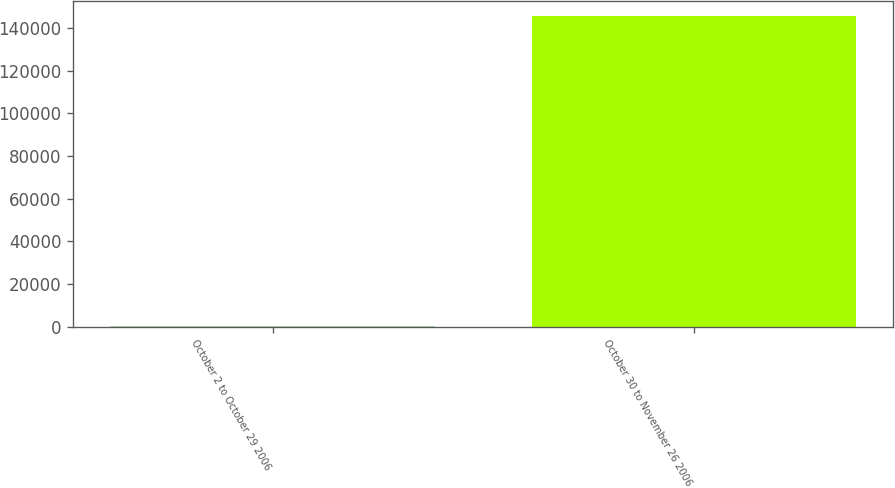Convert chart. <chart><loc_0><loc_0><loc_500><loc_500><bar_chart><fcel>October 2 to October 29 2006<fcel>October 30 to November 26 2006<nl><fcel>182<fcel>145487<nl></chart> 